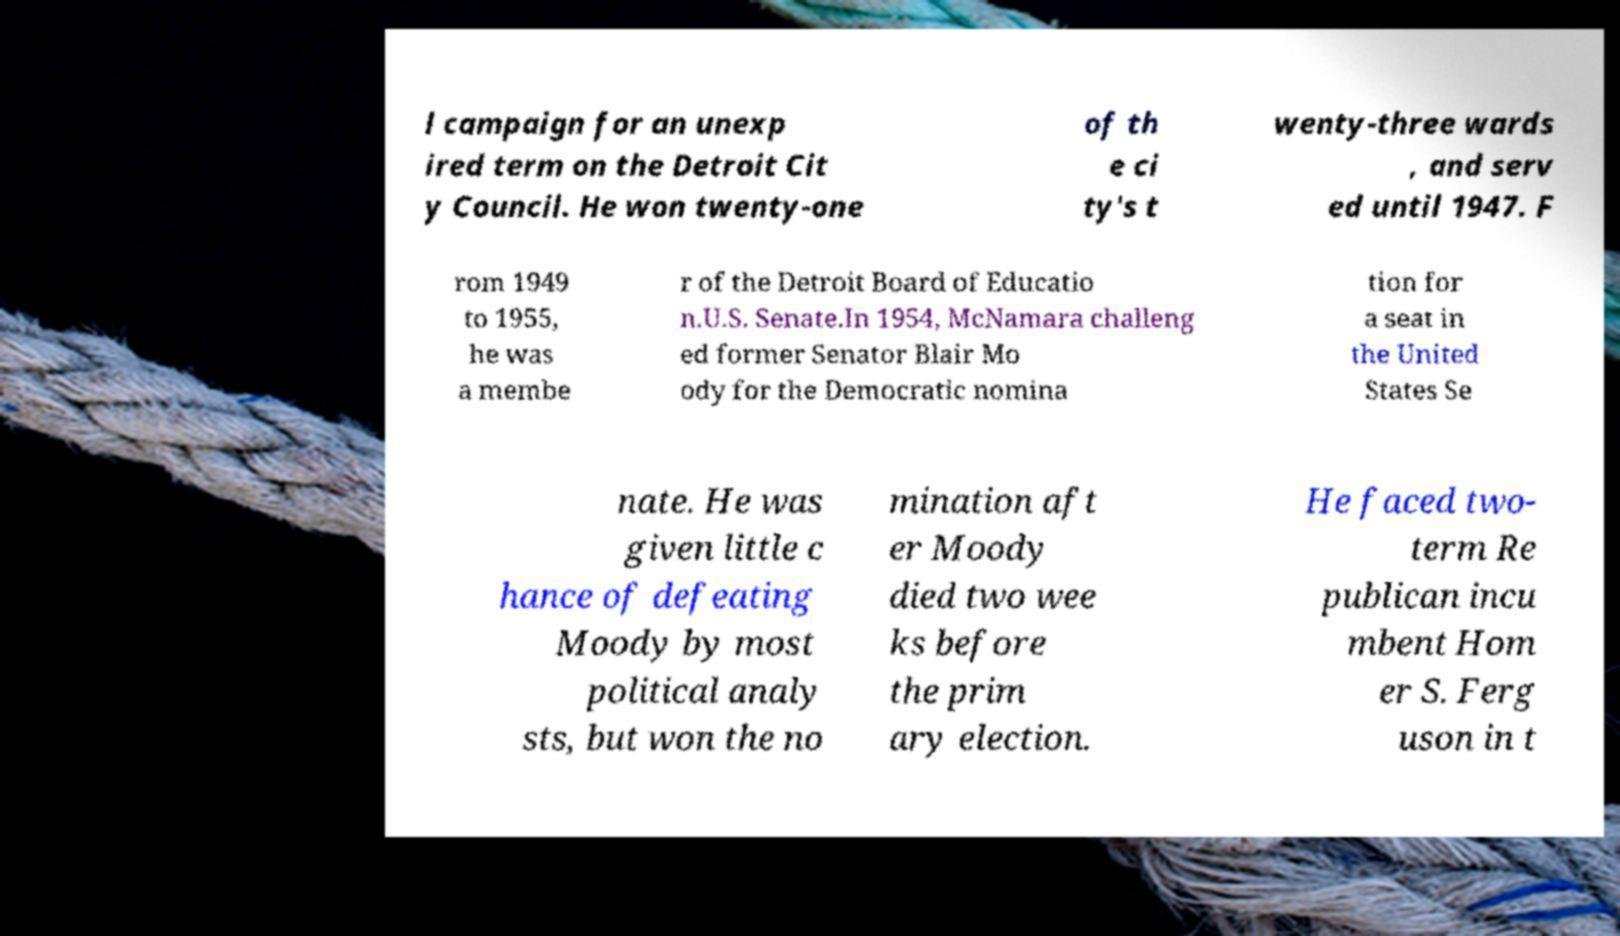Could you assist in decoding the text presented in this image and type it out clearly? l campaign for an unexp ired term on the Detroit Cit y Council. He won twenty-one of th e ci ty's t wenty-three wards , and serv ed until 1947. F rom 1949 to 1955, he was a membe r of the Detroit Board of Educatio n.U.S. Senate.In 1954, McNamara challeng ed former Senator Blair Mo ody for the Democratic nomina tion for a seat in the United States Se nate. He was given little c hance of defeating Moody by most political analy sts, but won the no mination aft er Moody died two wee ks before the prim ary election. He faced two- term Re publican incu mbent Hom er S. Ferg uson in t 